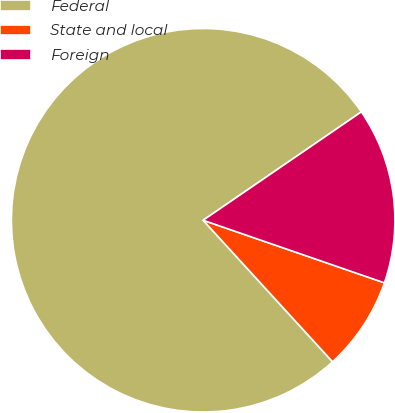Convert chart. <chart><loc_0><loc_0><loc_500><loc_500><pie_chart><fcel>Federal<fcel>State and local<fcel>Foreign<nl><fcel>77.23%<fcel>7.92%<fcel>14.85%<nl></chart> 